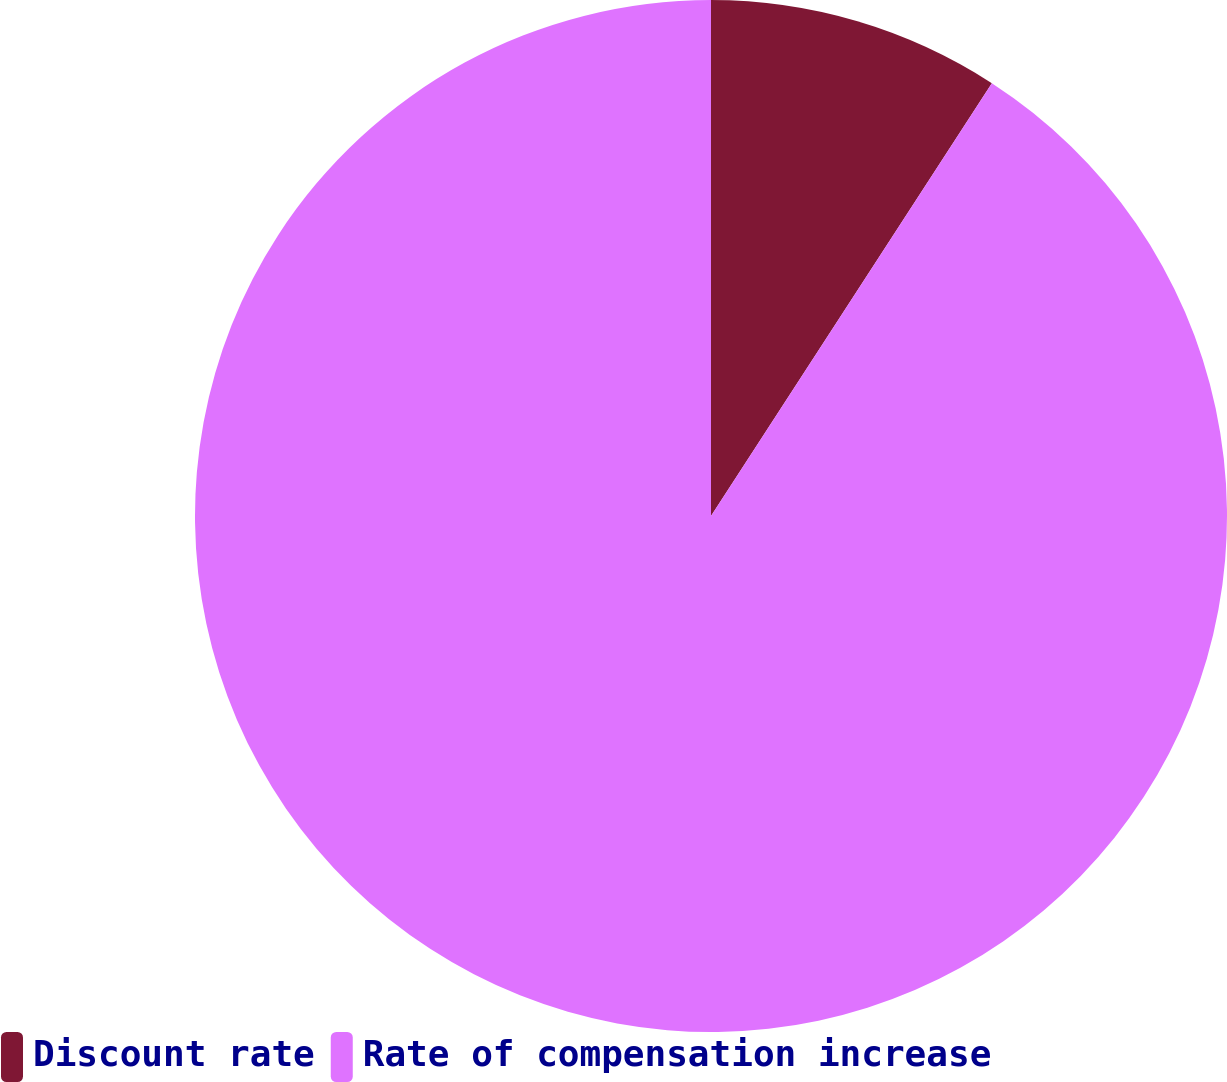<chart> <loc_0><loc_0><loc_500><loc_500><pie_chart><fcel>Discount rate<fcel>Rate of compensation increase<nl><fcel>9.16%<fcel>90.84%<nl></chart> 